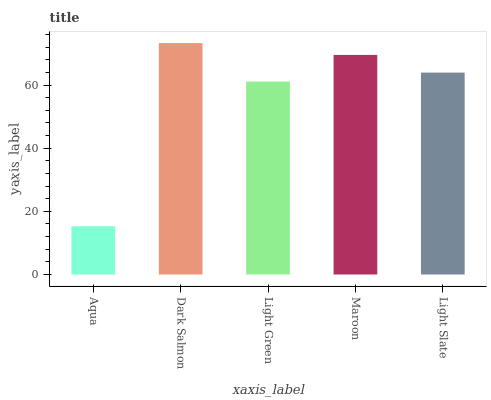Is Aqua the minimum?
Answer yes or no. Yes. Is Dark Salmon the maximum?
Answer yes or no. Yes. Is Light Green the minimum?
Answer yes or no. No. Is Light Green the maximum?
Answer yes or no. No. Is Dark Salmon greater than Light Green?
Answer yes or no. Yes. Is Light Green less than Dark Salmon?
Answer yes or no. Yes. Is Light Green greater than Dark Salmon?
Answer yes or no. No. Is Dark Salmon less than Light Green?
Answer yes or no. No. Is Light Slate the high median?
Answer yes or no. Yes. Is Light Slate the low median?
Answer yes or no. Yes. Is Maroon the high median?
Answer yes or no. No. Is Aqua the low median?
Answer yes or no. No. 